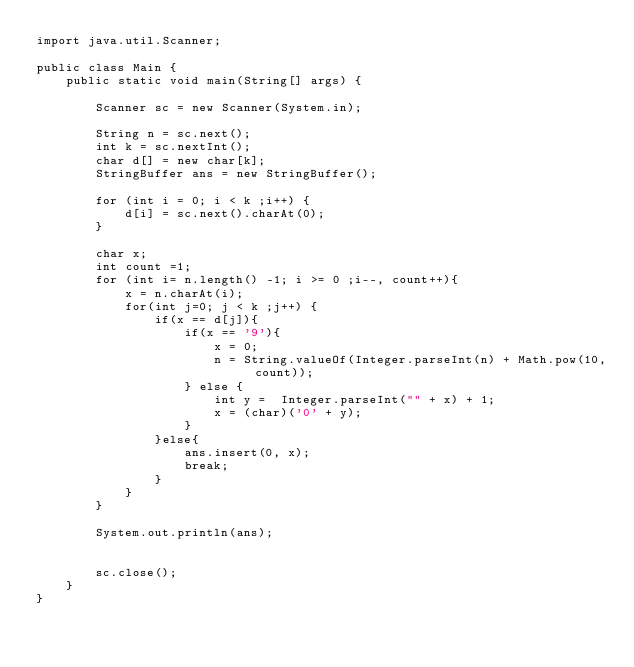Convert code to text. <code><loc_0><loc_0><loc_500><loc_500><_Java_>import java.util.Scanner;

public class Main {
	public static void main(String[] args) {

		Scanner sc = new Scanner(System.in);

		String n = sc.next();
		int k = sc.nextInt();
		char d[] = new char[k];
		StringBuffer ans = new StringBuffer();

		for (int i = 0; i < k ;i++) {
			d[i] = sc.next().charAt(0);
		}

		char x;
		int count =1;
		for (int i= n.length() -1; i >= 0 ;i--, count++){
			x = n.charAt(i);
			for(int j=0; j < k ;j++) {
				if(x == d[j]){
					if(x == '9'){
						x = 0;
						n = String.valueOf(Integer.parseInt(n) + Math.pow(10, count));
					} else {
						int y =  Integer.parseInt("" + x) + 1;
						x = (char)('0' + y);
					}
				}else{
					ans.insert(0, x);
					break;
				}
			}
		}

		System.out.println(ans);


		sc.close();
	}
}
</code> 